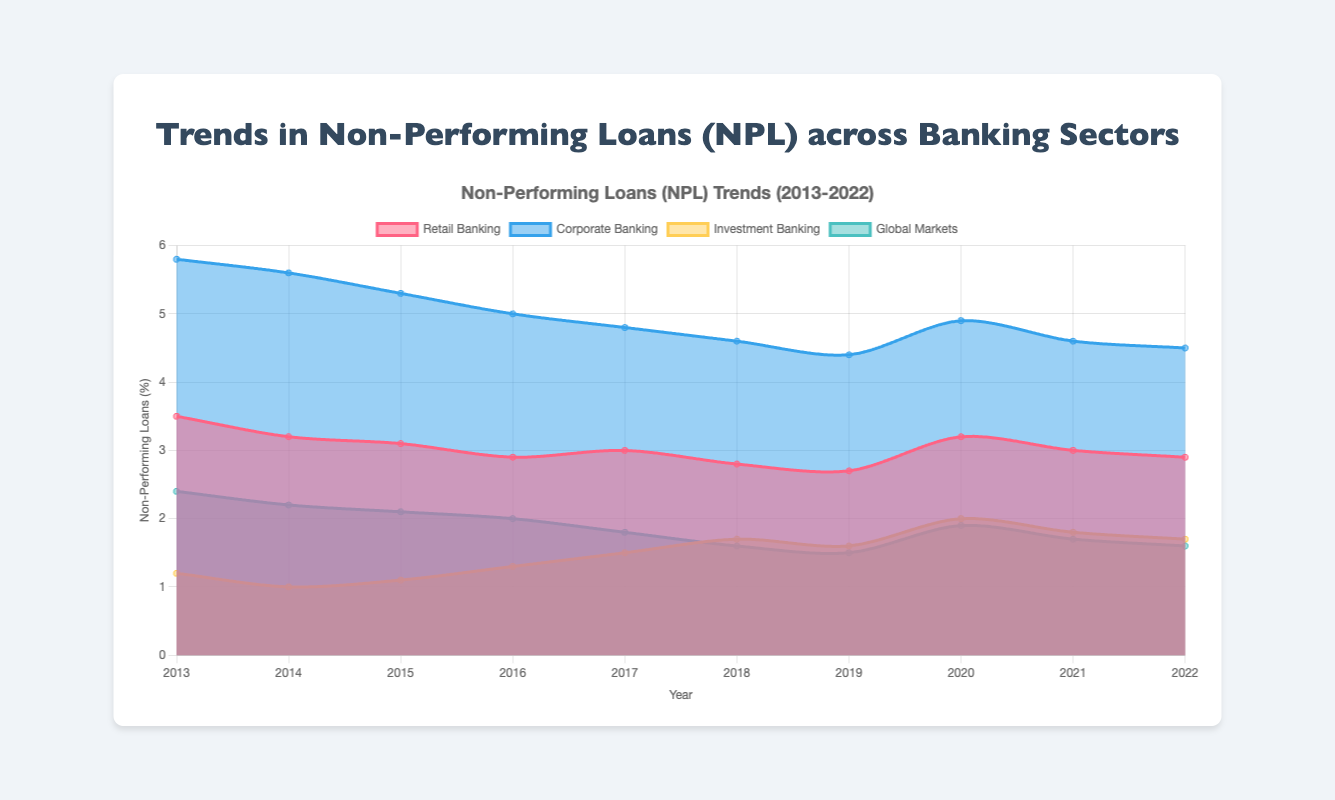What is the title of the chart? The title of the chart is located at the top center and it reads "Non-Performing Loans (NPL) Trends (2013-2022)".
Answer: Non-Performing Loans (NPL) Trends (2013-2022) Which banking sector has the highest NPL in 2015? The line representing "Corporate Banking" is at the highest position among all sectors in 2015.
Answer: Corporate Banking How did the NPL trend change for Retail Banking from 2013 to 2022? Tracking the Retail Banking line from 2013 to 2022, the NPL decreased from 3.5% to 2.9% with some fluctuation in between.
Answer: Decreased What is the average NPL of Global Markets for 2020 and 2021? The NPL for Global Markets in 2020 is 1.9% and in 2021 is 1.7%. Adding these together gives 3.6, and dividing by 2 gives an average of 1.8%.
Answer: 1.8% Which sector shows an increasing trend in NPLs from 2018 to 2020? The Investment Banking line increases from 1.7% in 2018 to 2.0% in 2020.
Answer: Investment Banking Compare the NPL percentages of Corporate Banking and Investment Banking in 2017. In 2017, Corporate Banking has an NPL of 4.8% while Investment Banking has an NPL of 1.5%.
Answer: Corporate Banking is higher Which year did Retail Banking have the lowest NPL? The minimum point in the Retail Banking line occurs in 2019, where the NPL is 2.7%.
Answer: 2019 How are the colors differentiated for the sectors? Retail Banking is represented by a pinkish color, Corporate Banking by a bluish color, Investment Banking by a yellowish color, and Global Markets by a greenish color.
Answer: Pink, Blue, Yellow, Green What is the difference in NPL between Corporate Banking and Global Markets in 2022? In 2022, the NPL for Corporate Banking is 4.5% and for Global Markets it is 1.6%. The difference is 4.5% - 1.6% = 2.9%.
Answer: 2.9% 